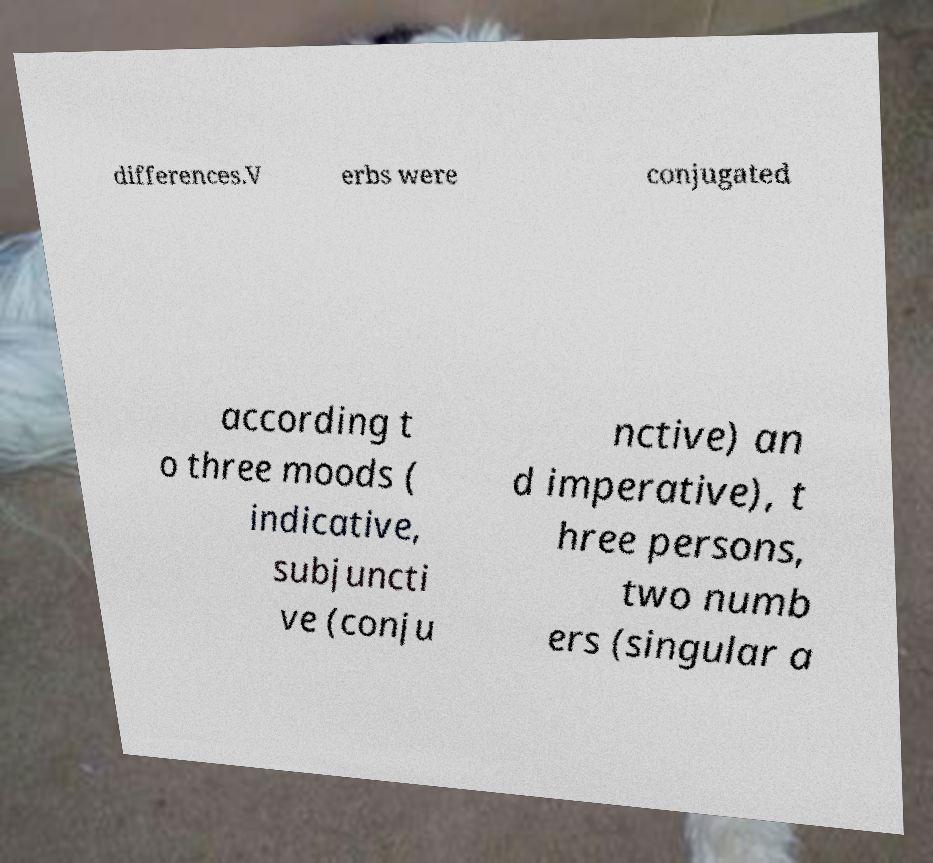Can you accurately transcribe the text from the provided image for me? differences.V erbs were conjugated according t o three moods ( indicative, subjuncti ve (conju nctive) an d imperative), t hree persons, two numb ers (singular a 